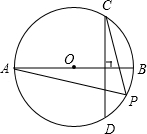First perform reasoning, then finally select the question from the choices in the following format: Answer: xxx.
Question: Given the figure provided, with AB serving as the diameter of circle O and chord CD being perpendicular to AB, if point P is located on arc CD (excluding points C and D), and if the degree measure of arc BD is 50.0 degrees, what is the degree measure of angle CPA?
Choices:
A: 65°
B: 50°
C: 130°
D: 100° Solution: 
Since AB is the diameter of circle O and CD is perpendicular to AB, we have angle BD = angle BC. Given that the angle angle BC is 50°, we can conclude that the angle angle AC is 130°. Therefore, angle CPA = 65°. Therefore, the correct answer is A.
Answer:A 